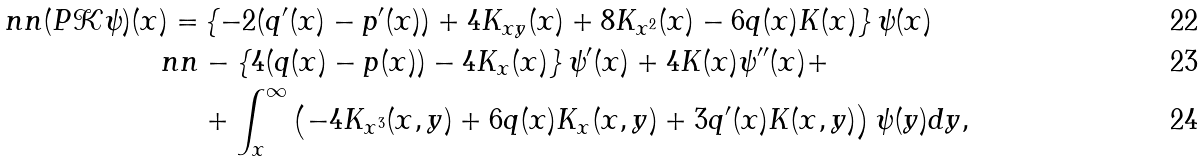Convert formula to latex. <formula><loc_0><loc_0><loc_500><loc_500>\ n n ( P \mathcal { K } \psi ) ( x ) = & \left \{ - 2 ( q ^ { \prime } ( x ) - p ^ { \prime } ( x ) ) + 4 K _ { x y } ( x ) + 8 K _ { x ^ { 2 } } ( x ) - 6 q ( x ) K ( x ) \right \} \psi ( x ) \\ \ n n & - \left \{ 4 ( q ( x ) - p ( x ) ) - 4 K _ { x } ( x ) \right \} \psi ^ { \prime } ( x ) + 4 K ( x ) \psi ^ { \prime \prime } ( x ) + \\ & + \int _ { x } ^ { \infty } \left ( - 4 K _ { x ^ { 3 } } ( x , y ) + 6 q ( x ) K _ { x } ( x , y ) + 3 q ^ { \prime } ( x ) K ( x , y ) \right ) \psi ( y ) d y ,</formula> 